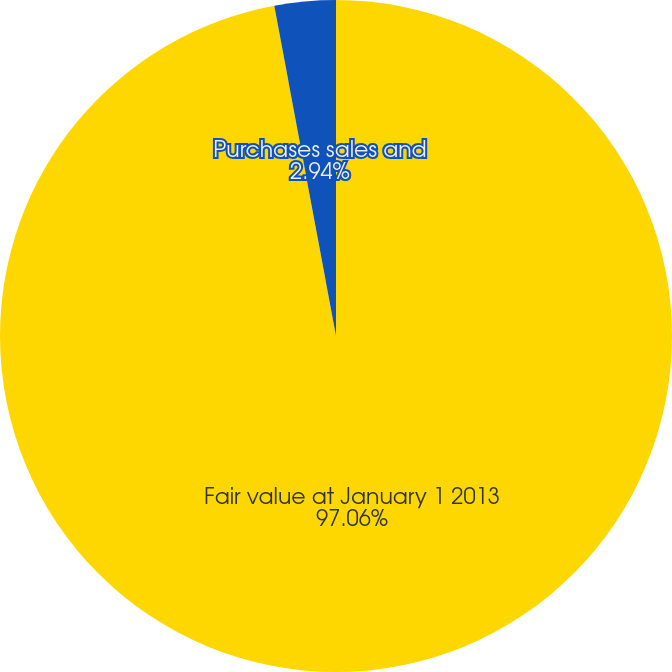Convert chart to OTSL. <chart><loc_0><loc_0><loc_500><loc_500><pie_chart><fcel>Fair value at January 1 2013<fcel>Purchases sales and<nl><fcel>97.06%<fcel>2.94%<nl></chart> 